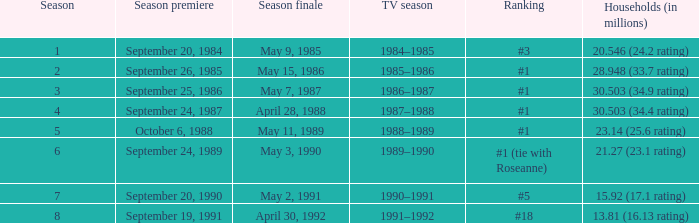Which television season has 30.503 million households and a 34.9 rating? 1986–1987. 